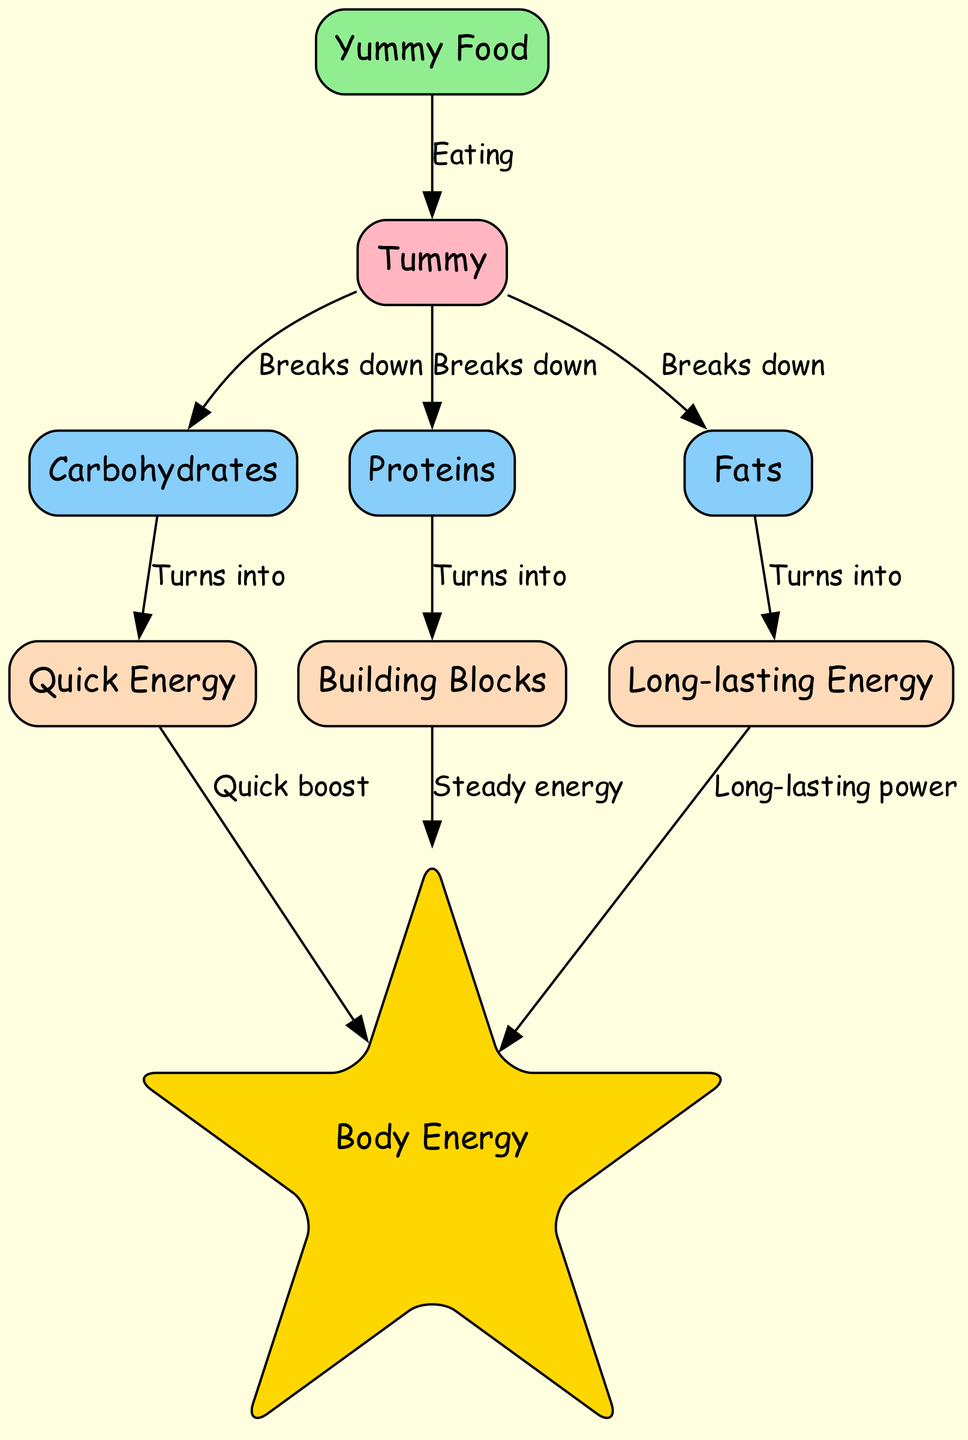What is the starting point in the diagram? The diagram starts with the node labeled "Yummy Food," which represents the intake of food. This is the first node that initiates the process of energy conversion.
Answer: Yummy Food How many types of macronutrients are shown? The diagram identifies three types of macronutrients: carbohydrates, proteins, and fats, which are shown as separate nodes in the visual.
Answer: Three What substance do carbohydrates turn into? According to the diagram, carbohydrates convert into "Quick Energy," which is represented as glucose. This transformation occurs after they are broken down in the stomach.
Answer: Quick Energy What energy source provides long-lasting power? The diagram indicates that "Long-lasting Energy" comes from fatty acids, which are produced from fats after being processed in the stomach.
Answer: Long-lasting Energy Which component is obtained from proteins? The diagram shows that proteins turn into "Building Blocks," which are identified as amino acids. This process occurs after proteins are broken down in the stomach.
Answer: Building Blocks What is the link between glucose and energy? The diagram shows that glucose provides a "Quick boost" to energy, indicating that after carbohydrates turn into glucose, it contributes to energy levels rapidly.
Answer: Quick boost How does the body use amino acids? The diagram illustrates that amino acids provide "Steady energy," meaning that they contribute to a more gradual and sustained energy release once they are formed from proteins.
Answer: Steady energy Which macronutrient is the last to contribute to energy? According to the flow of the diagram, fats are the last to convert into energy, which is categorized as long-lasting power through fatty acids. This shows a progression from carbohydrates to proteins to fats.
Answer: Fats What happens to food in the stomach? In the stomach, food is broken down into its constituent macronutrients: carbohydrates, proteins, and fats, as depicted in the edges leading away from the stomach node.
Answer: Breaks down 